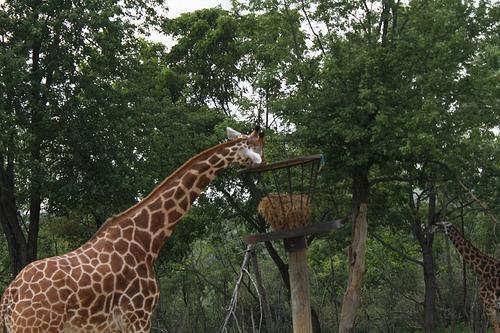How many feeder baskets are pictured?
Give a very brief answer. 1. How many giraffes are shown?
Give a very brief answer. 2. 